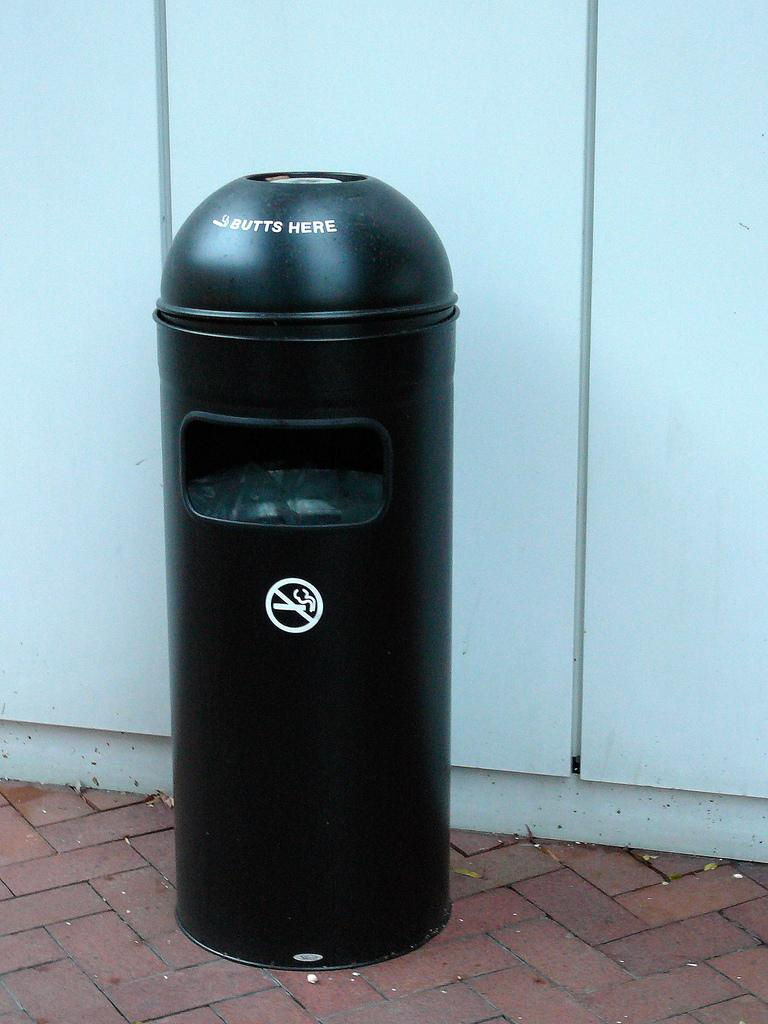<image>
Write a terse but informative summary of the picture. A black trash can on a brick sidewalk says Butts Here on the lid. 